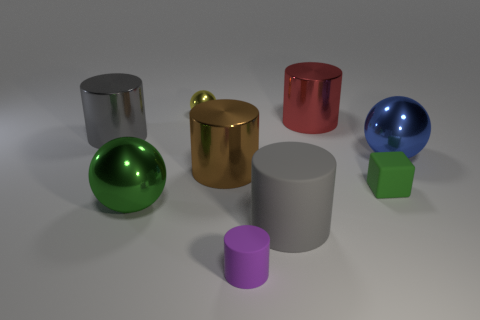Subtract all big spheres. How many spheres are left? 1 Add 1 tiny green objects. How many objects exist? 10 Subtract all blue blocks. How many gray cylinders are left? 2 Subtract all blocks. How many objects are left? 8 Subtract all yellow balls. How many balls are left? 2 Subtract all brown cylinders. Subtract all large blue balls. How many objects are left? 7 Add 6 big green balls. How many big green balls are left? 7 Add 5 tiny gray things. How many tiny gray things exist? 5 Subtract 0 gray cubes. How many objects are left? 9 Subtract all yellow cylinders. Subtract all blue spheres. How many cylinders are left? 5 